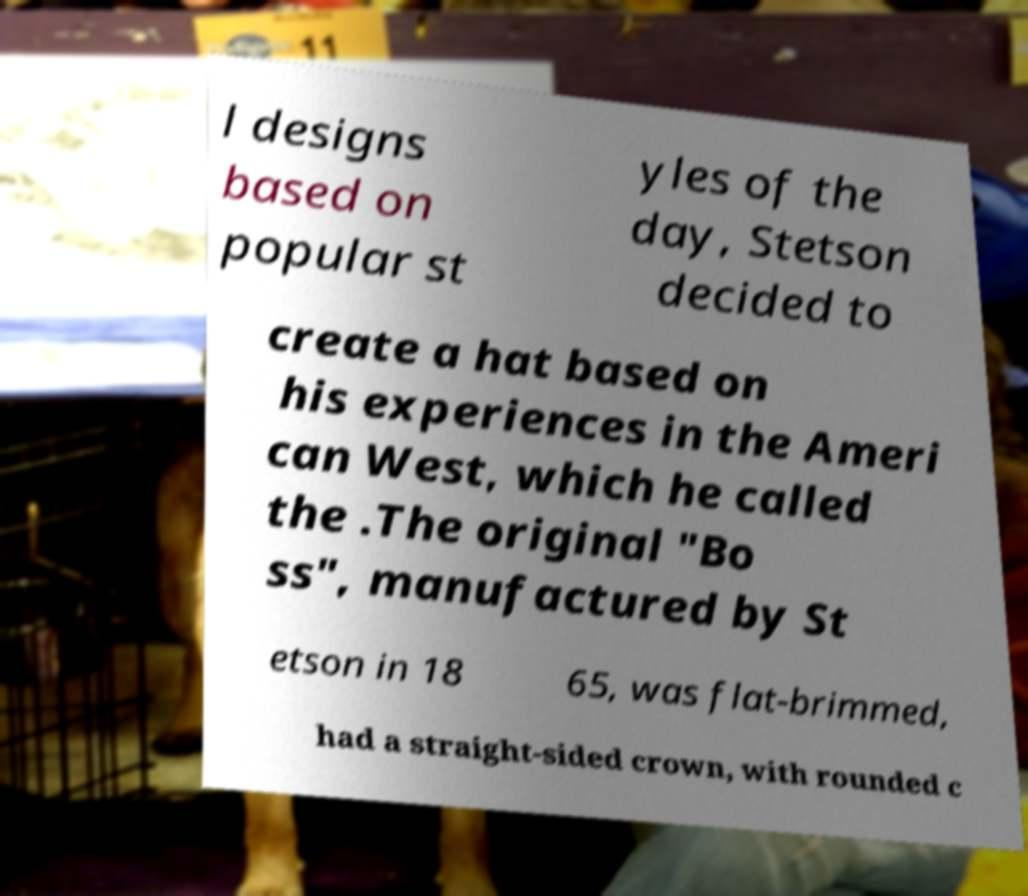I need the written content from this picture converted into text. Can you do that? l designs based on popular st yles of the day, Stetson decided to create a hat based on his experiences in the Ameri can West, which he called the .The original "Bo ss", manufactured by St etson in 18 65, was flat-brimmed, had a straight-sided crown, with rounded c 